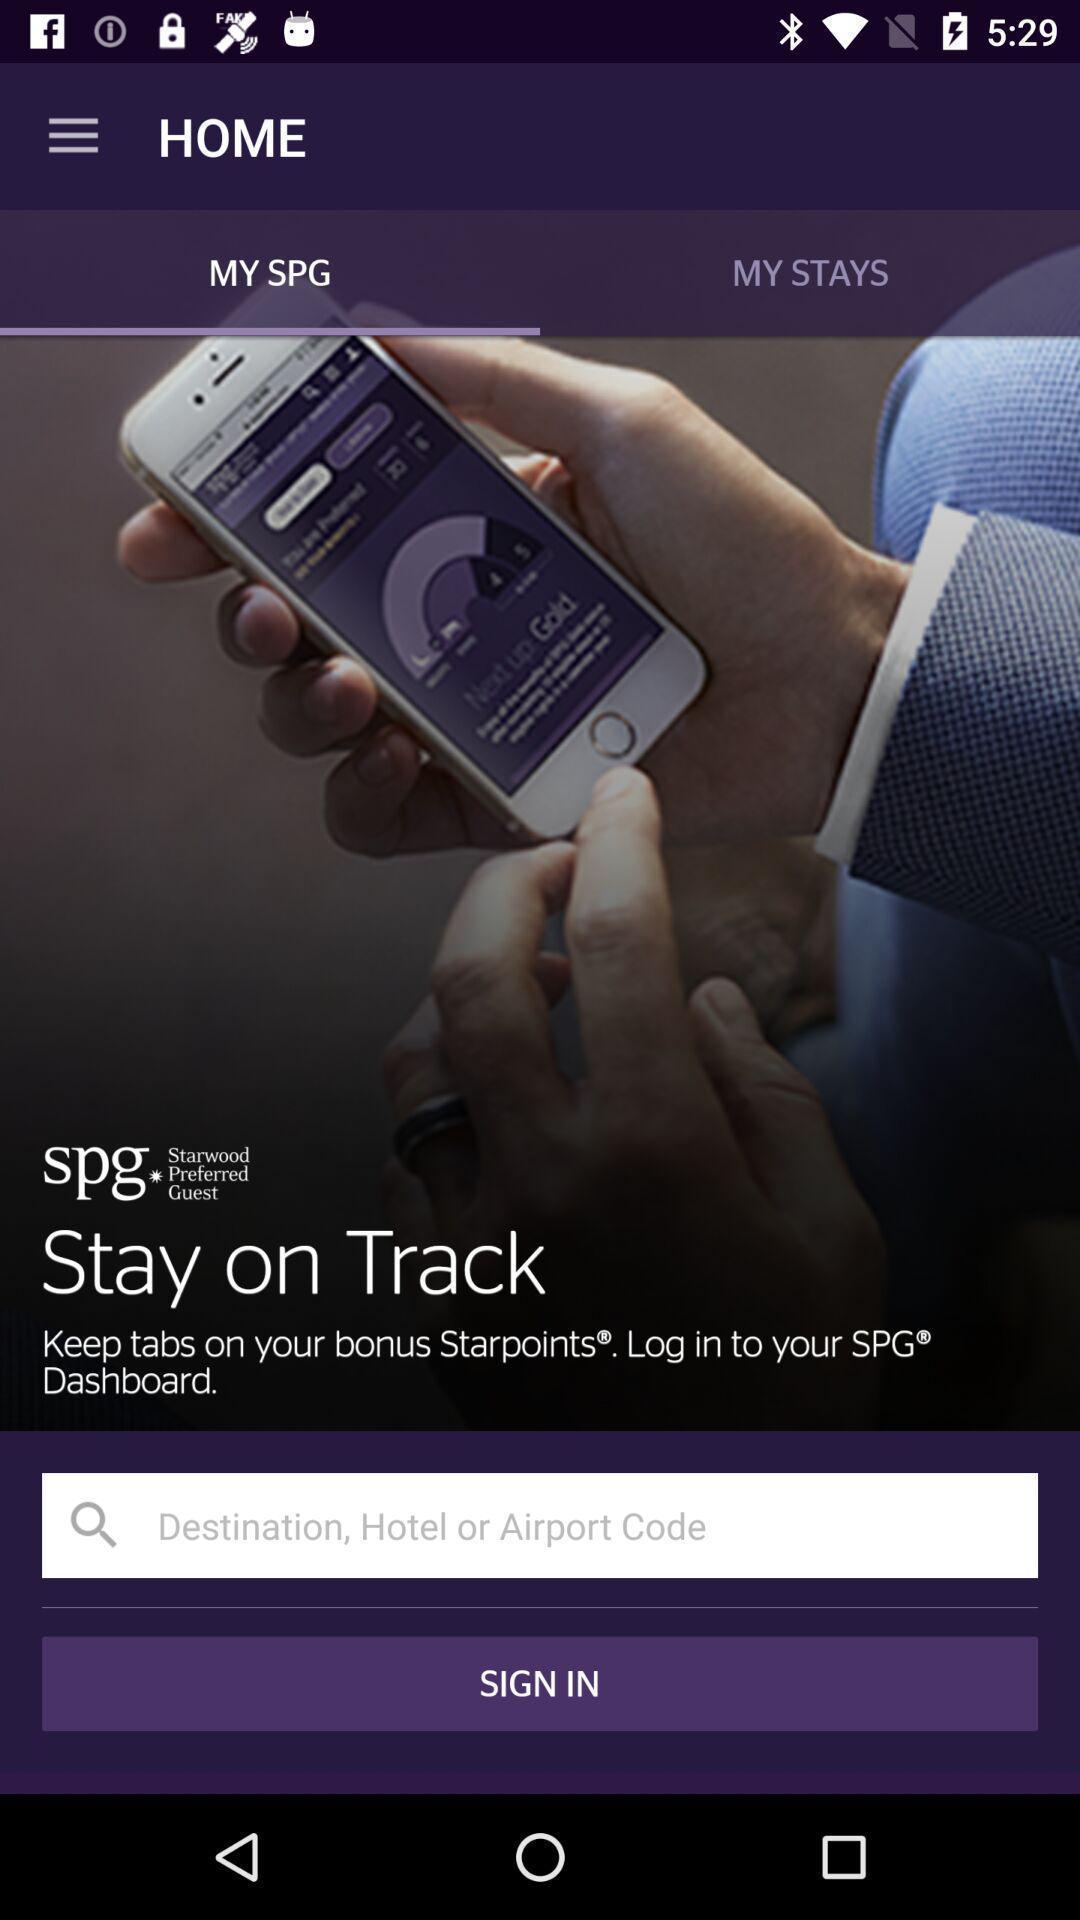Summarize the main components in this picture. Welcome page. 